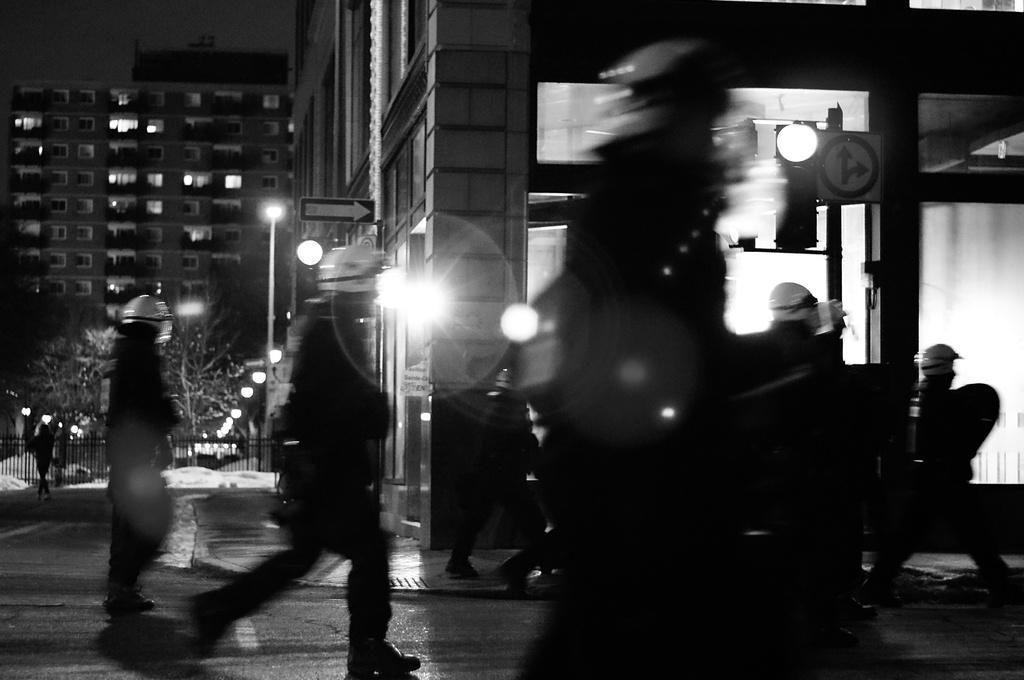Could you give a brief overview of what you see in this image? In this picture we can see some people on the road, traffic signal, lights, poles, sign boards, trees, buildings with windows and some objects and these group of people wore helmets and in the background it is dark. 